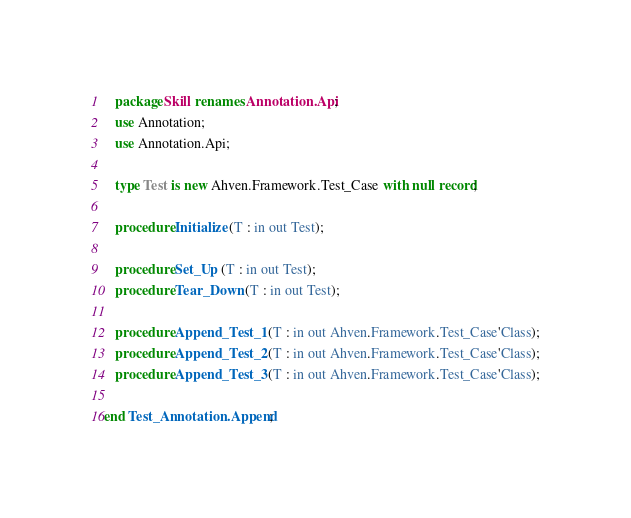<code> <loc_0><loc_0><loc_500><loc_500><_Ada_>   package Skill renames Annotation.Api;
   use Annotation;
   use Annotation.Api;

   type Test is new Ahven.Framework.Test_Case with null record;

   procedure Initialize (T : in out Test);

   procedure Set_Up (T : in out Test);
   procedure Tear_Down (T : in out Test);

   procedure Append_Test_1 (T : in out Ahven.Framework.Test_Case'Class);
   procedure Append_Test_2 (T : in out Ahven.Framework.Test_Case'Class);
   procedure Append_Test_3 (T : in out Ahven.Framework.Test_Case'Class);

end Test_Annotation.Append;
</code> 